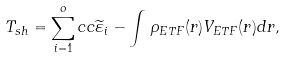<formula> <loc_0><loc_0><loc_500><loc_500>T _ { s h } = \sum _ { i = 1 } ^ { o } c c \widetilde { \varepsilon } _ { i } - \int \, \rho _ { E T F } ( { r } ) V _ { E T F } ( { r } ) d { r } ,</formula> 